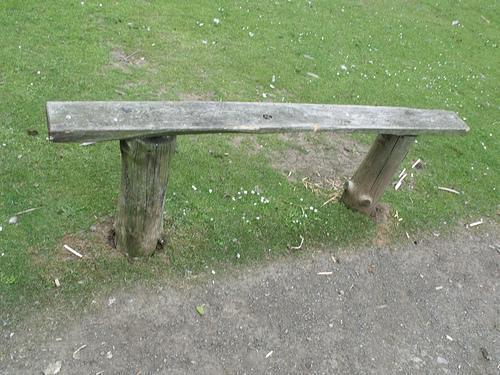How many benches are there?
Give a very brief answer. 1. 